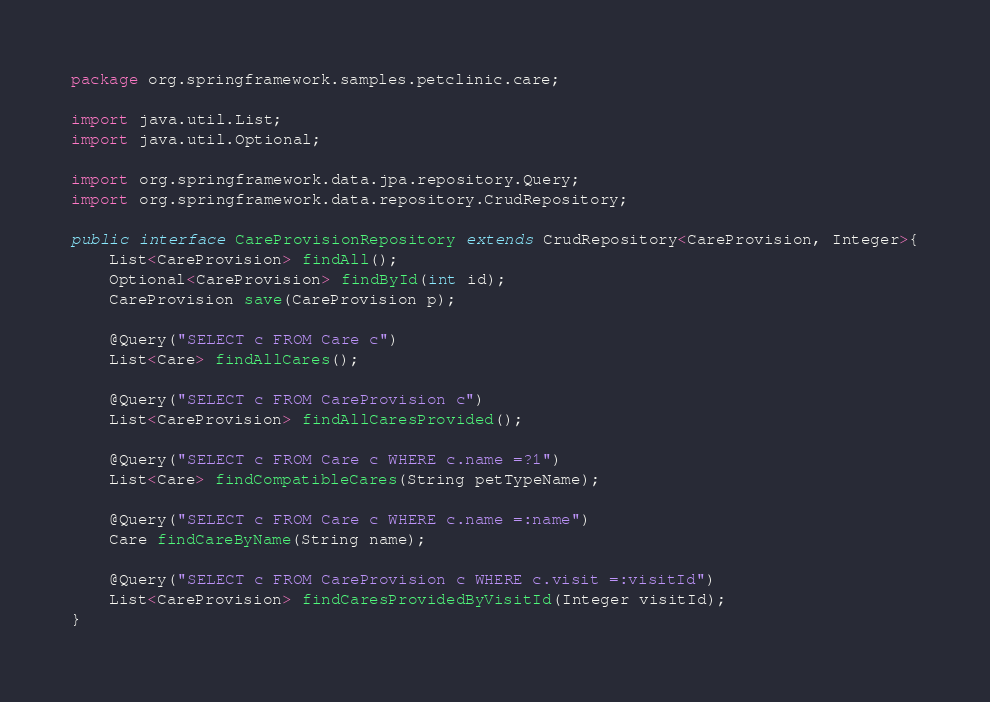Convert code to text. <code><loc_0><loc_0><loc_500><loc_500><_Java_>package org.springframework.samples.petclinic.care;

import java.util.List;
import java.util.Optional;

import org.springframework.data.jpa.repository.Query;
import org.springframework.data.repository.CrudRepository;

public interface CareProvisionRepository extends CrudRepository<CareProvision, Integer>{
    List<CareProvision> findAll();        
    Optional<CareProvision> findById(int id);
    CareProvision save(CareProvision p);
    
    @Query("SELECT c FROM Care c")
	List<Care> findAllCares();
    
    @Query("SELECT c FROM CareProvision c")
    List<CareProvision> findAllCaresProvided();
    
    @Query("SELECT c FROM Care c WHERE c.name =?1")
    List<Care> findCompatibleCares(String petTypeName);
    
    @Query("SELECT c FROM Care c WHERE c.name =:name")
    Care findCareByName(String name);
    
    @Query("SELECT c FROM CareProvision c WHERE c.visit =:visitId")
    List<CareProvision> findCaresProvidedByVisitId(Integer visitId);
}
</code> 